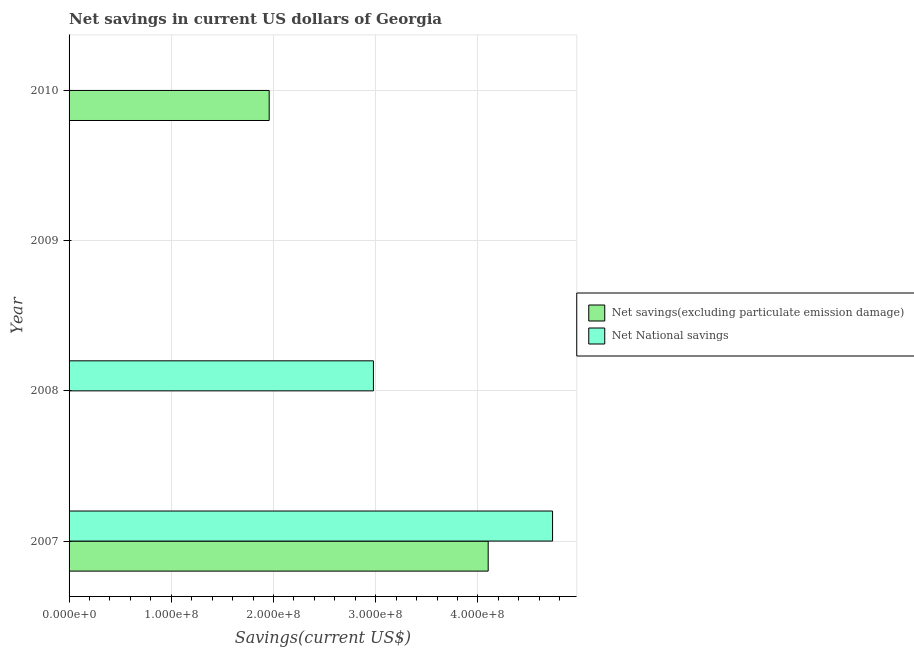Are the number of bars per tick equal to the number of legend labels?
Ensure brevity in your answer.  No. Are the number of bars on each tick of the Y-axis equal?
Your answer should be very brief. No. How many bars are there on the 4th tick from the top?
Make the answer very short. 2. Across all years, what is the maximum net savings(excluding particulate emission damage)?
Ensure brevity in your answer.  4.10e+08. What is the total net savings(excluding particulate emission damage) in the graph?
Your answer should be compact. 6.06e+08. What is the difference between the net national savings in 2007 and that in 2008?
Ensure brevity in your answer.  1.75e+08. What is the difference between the net national savings in 2008 and the net savings(excluding particulate emission damage) in 2007?
Provide a succinct answer. -1.12e+08. What is the average net national savings per year?
Your response must be concise. 1.93e+08. In the year 2007, what is the difference between the net savings(excluding particulate emission damage) and net national savings?
Offer a terse response. -6.30e+07. What is the ratio of the net savings(excluding particulate emission damage) in 2007 to that in 2010?
Your response must be concise. 2.09. What is the difference between the highest and the lowest net savings(excluding particulate emission damage)?
Offer a very short reply. 4.10e+08. In how many years, is the net savings(excluding particulate emission damage) greater than the average net savings(excluding particulate emission damage) taken over all years?
Your answer should be compact. 2. How many bars are there?
Make the answer very short. 4. Are all the bars in the graph horizontal?
Provide a short and direct response. Yes. How many years are there in the graph?
Give a very brief answer. 4. Does the graph contain grids?
Keep it short and to the point. Yes. How many legend labels are there?
Give a very brief answer. 2. What is the title of the graph?
Keep it short and to the point. Net savings in current US dollars of Georgia. Does "Formally registered" appear as one of the legend labels in the graph?
Your answer should be compact. No. What is the label or title of the X-axis?
Offer a very short reply. Savings(current US$). What is the label or title of the Y-axis?
Provide a short and direct response. Year. What is the Savings(current US$) of Net savings(excluding particulate emission damage) in 2007?
Offer a very short reply. 4.10e+08. What is the Savings(current US$) in Net National savings in 2007?
Your answer should be very brief. 4.73e+08. What is the Savings(current US$) in Net National savings in 2008?
Give a very brief answer. 2.98e+08. What is the Savings(current US$) in Net savings(excluding particulate emission damage) in 2010?
Offer a terse response. 1.96e+08. Across all years, what is the maximum Savings(current US$) in Net savings(excluding particulate emission damage)?
Offer a very short reply. 4.10e+08. Across all years, what is the maximum Savings(current US$) of Net National savings?
Ensure brevity in your answer.  4.73e+08. Across all years, what is the minimum Savings(current US$) in Net savings(excluding particulate emission damage)?
Provide a succinct answer. 0. What is the total Savings(current US$) in Net savings(excluding particulate emission damage) in the graph?
Ensure brevity in your answer.  6.06e+08. What is the total Savings(current US$) of Net National savings in the graph?
Offer a terse response. 7.71e+08. What is the difference between the Savings(current US$) of Net National savings in 2007 and that in 2008?
Ensure brevity in your answer.  1.75e+08. What is the difference between the Savings(current US$) in Net savings(excluding particulate emission damage) in 2007 and that in 2010?
Your answer should be very brief. 2.14e+08. What is the difference between the Savings(current US$) of Net savings(excluding particulate emission damage) in 2007 and the Savings(current US$) of Net National savings in 2008?
Your response must be concise. 1.12e+08. What is the average Savings(current US$) of Net savings(excluding particulate emission damage) per year?
Offer a terse response. 1.51e+08. What is the average Savings(current US$) of Net National savings per year?
Your response must be concise. 1.93e+08. In the year 2007, what is the difference between the Savings(current US$) in Net savings(excluding particulate emission damage) and Savings(current US$) in Net National savings?
Your answer should be compact. -6.30e+07. What is the ratio of the Savings(current US$) of Net National savings in 2007 to that in 2008?
Provide a short and direct response. 1.59. What is the ratio of the Savings(current US$) of Net savings(excluding particulate emission damage) in 2007 to that in 2010?
Your answer should be very brief. 2.09. What is the difference between the highest and the lowest Savings(current US$) of Net savings(excluding particulate emission damage)?
Give a very brief answer. 4.10e+08. What is the difference between the highest and the lowest Savings(current US$) of Net National savings?
Your answer should be very brief. 4.73e+08. 